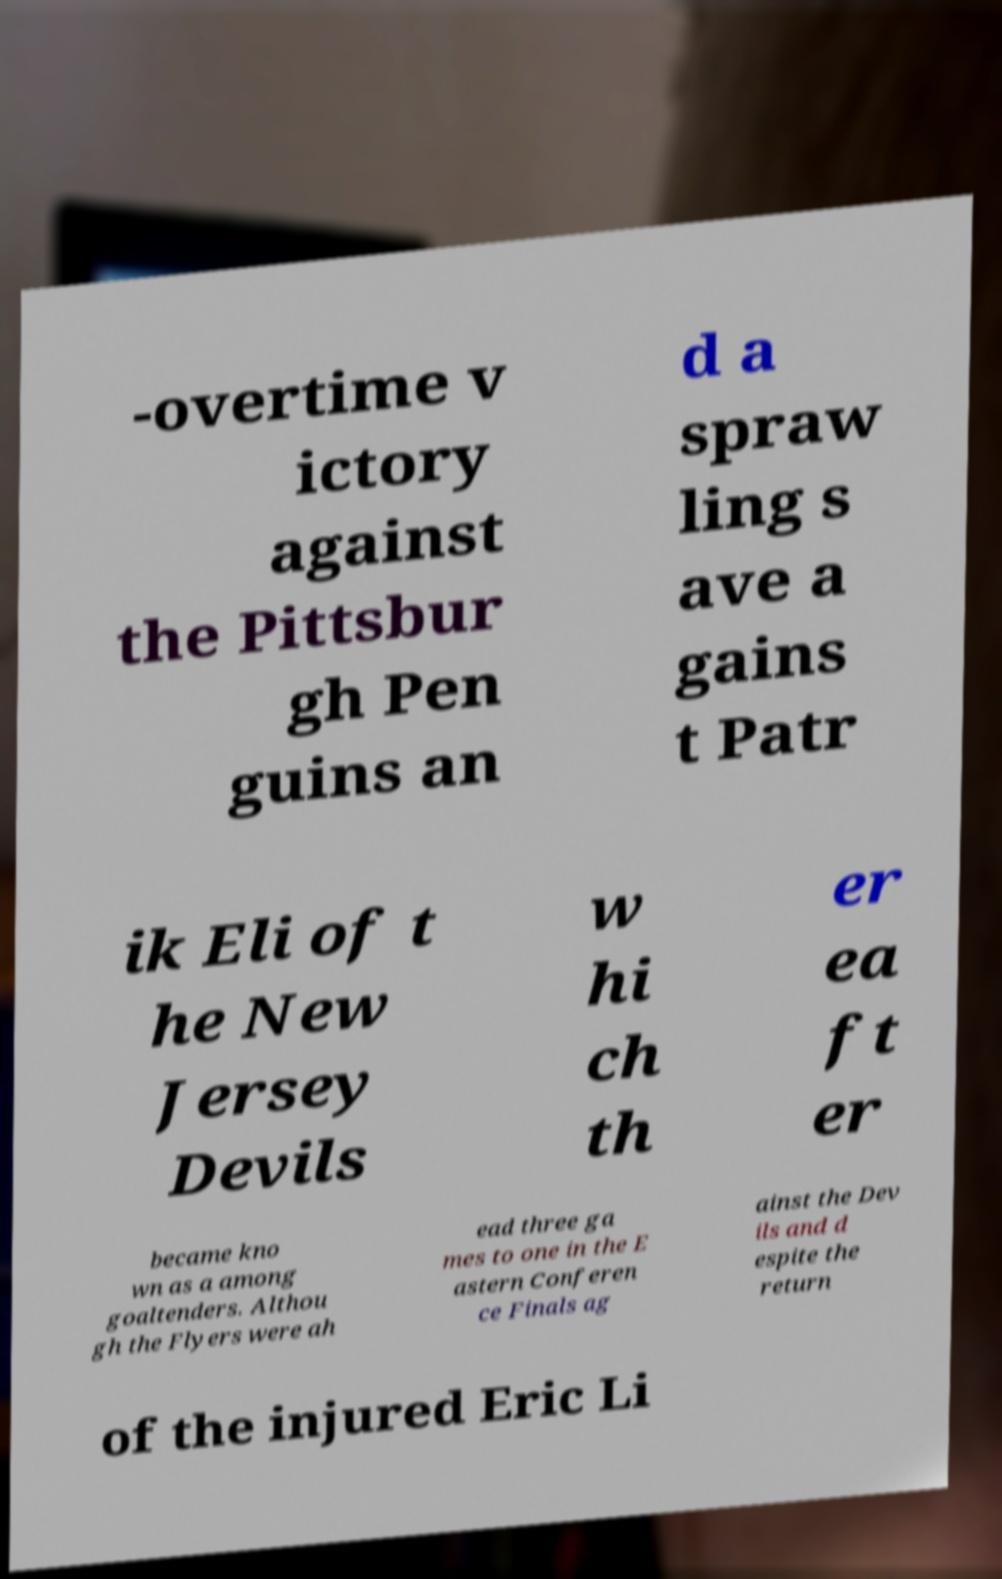I need the written content from this picture converted into text. Can you do that? -overtime v ictory against the Pittsbur gh Pen guins an d a spraw ling s ave a gains t Patr ik Eli of t he New Jersey Devils w hi ch th er ea ft er became kno wn as a among goaltenders. Althou gh the Flyers were ah ead three ga mes to one in the E astern Conferen ce Finals ag ainst the Dev ils and d espite the return of the injured Eric Li 